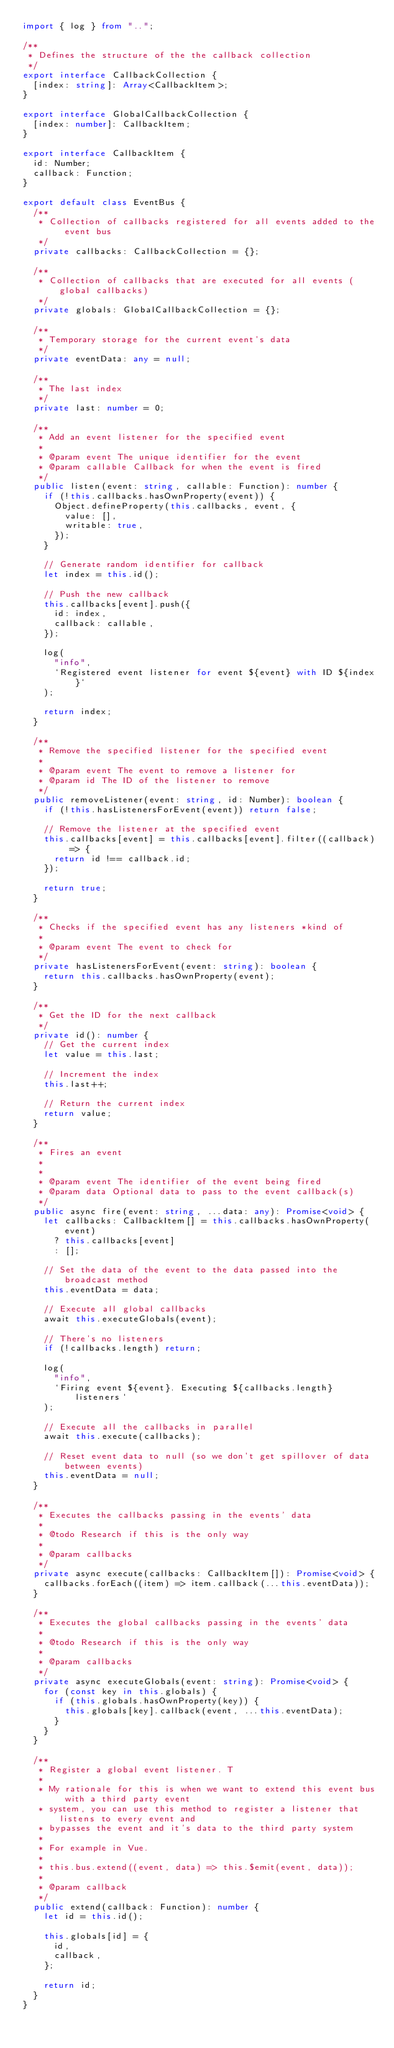Convert code to text. <code><loc_0><loc_0><loc_500><loc_500><_TypeScript_>import { log } from "..";

/**
 * Defines the structure of the the callback collection
 */
export interface CallbackCollection {
  [index: string]: Array<CallbackItem>;
}

export interface GlobalCallbackCollection {
  [index: number]: CallbackItem;
}

export interface CallbackItem {
  id: Number;
  callback: Function;
}

export default class EventBus {
  /**
   * Collection of callbacks registered for all events added to the event bus
   */
  private callbacks: CallbackCollection = {};

  /**
   * Collection of callbacks that are executed for all events (global callbacks)
   */
  private globals: GlobalCallbackCollection = {};

  /**
   * Temporary storage for the current event's data
   */
  private eventData: any = null;

  /**
   * The last index
   */
  private last: number = 0;

  /**
   * Add an event listener for the specified event
   *
   * @param event The unique identifier for the event
   * @param callable Callback for when the event is fired
   */
  public listen(event: string, callable: Function): number {
    if (!this.callbacks.hasOwnProperty(event)) {
      Object.defineProperty(this.callbacks, event, {
        value: [],
        writable: true,
      });
    }

    // Generate random identifier for callback
    let index = this.id();

    // Push the new callback
    this.callbacks[event].push({
      id: index,
      callback: callable,
    });

    log(
      "info",
      `Registered event listener for event ${event} with ID ${index}`
    );

    return index;
  }

  /**
   * Remove the specified listener for the specified event
   *
   * @param event The event to remove a listener for
   * @param id The ID of the listener to remove
   */
  public removeListener(event: string, id: Number): boolean {
    if (!this.hasListenersForEvent(event)) return false;

    // Remove the listener at the specified event
    this.callbacks[event] = this.callbacks[event].filter((callback) => {
      return id !== callback.id;
    });

    return true;
  }

  /**
   * Checks if the specified event has any listeners *kind of
   *
   * @param event The event to check for
   */
  private hasListenersForEvent(event: string): boolean {
    return this.callbacks.hasOwnProperty(event);
  }

  /**
   * Get the ID for the next callback
   */
  private id(): number {
    // Get the current index
    let value = this.last;

    // Increment the index
    this.last++;

    // Return the current index
    return value;
  }

  /**
   * Fires an event
   *
   *
   * @param event The identifier of the event being fired
   * @param data Optional data to pass to the event callback(s)
   */
  public async fire(event: string, ...data: any): Promise<void> {
    let callbacks: CallbackItem[] = this.callbacks.hasOwnProperty(event)
      ? this.callbacks[event]
      : [];

    // Set the data of the event to the data passed into the broadcast method
    this.eventData = data;

    // Execute all global callbacks
    await this.executeGlobals(event);

    // There's no listeners
    if (!callbacks.length) return;

    log(
      "info",
      `Firing event ${event}. Executing ${callbacks.length} listeners`
    );

    // Execute all the callbacks in parallel
    await this.execute(callbacks);

    // Reset event data to null (so we don't get spillover of data between events)
    this.eventData = null;
  }

  /**
   * Executes the callbacks passing in the events' data
   *
   * @todo Research if this is the only way
   *
   * @param callbacks
   */
  private async execute(callbacks: CallbackItem[]): Promise<void> {
    callbacks.forEach((item) => item.callback(...this.eventData));
  }

  /**
   * Executes the global callbacks passing in the events' data
   *
   * @todo Research if this is the only way
   *
   * @param callbacks
   */
  private async executeGlobals(event: string): Promise<void> {
    for (const key in this.globals) {
      if (this.globals.hasOwnProperty(key)) {
        this.globals[key].callback(event, ...this.eventData);
      }
    }
  }

  /**
   * Register a global event listener. T
   *
   * My rationale for this is when we want to extend this event bus with a third party event
   * system, you can use this method to register a listener that listens to every event and
   * bypasses the event and it's data to the third party system
   *
   * For example in Vue.
   *
   * this.bus.extend((event, data) => this.$emit(event, data));
   *
   * @param callback
   */
  public extend(callback: Function): number {
    let id = this.id();

    this.globals[id] = {
      id,
      callback,
    };

    return id;
  }
}
</code> 